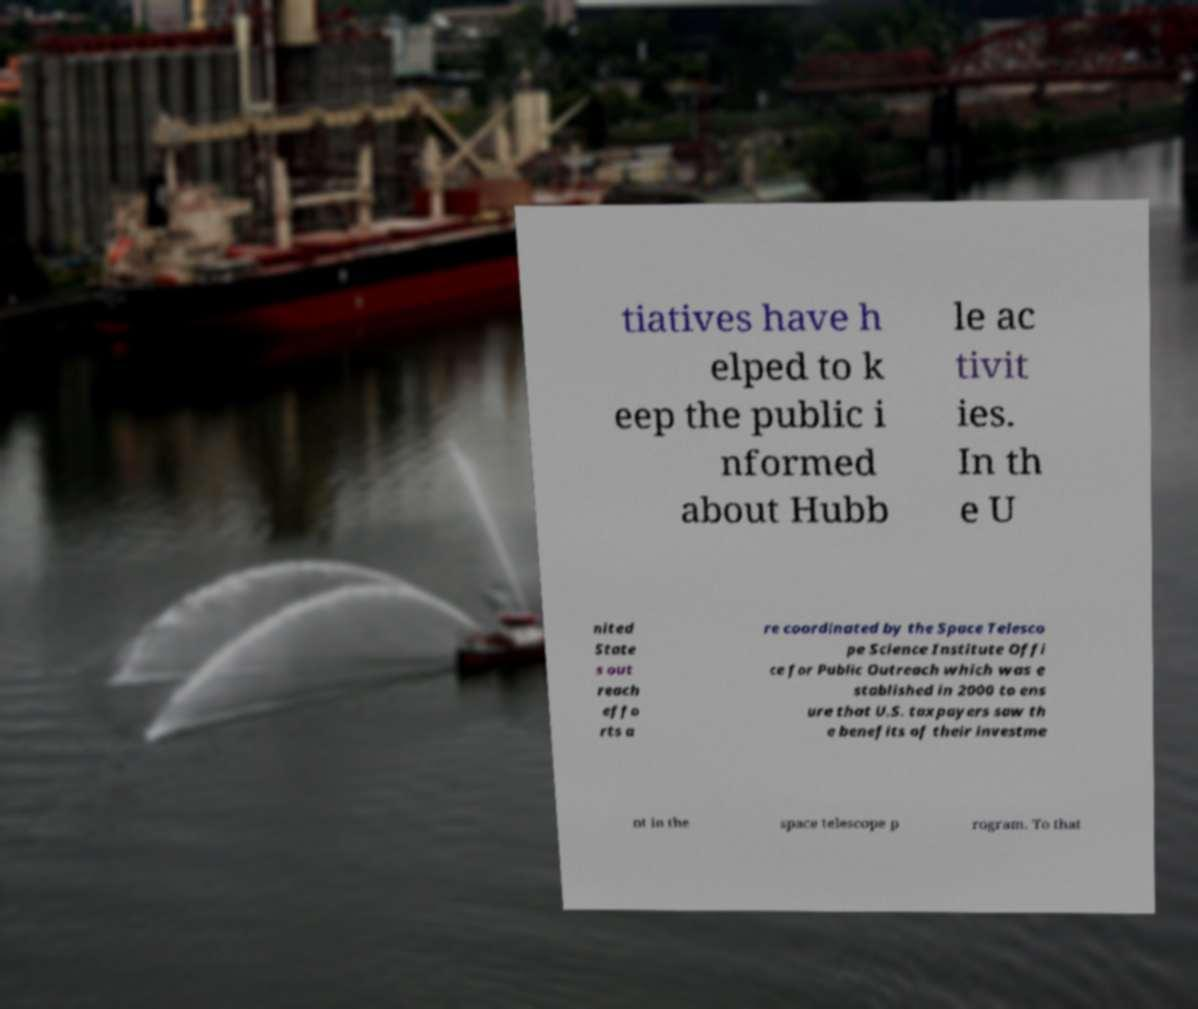For documentation purposes, I need the text within this image transcribed. Could you provide that? tiatives have h elped to k eep the public i nformed about Hubb le ac tivit ies. In th e U nited State s out reach effo rts a re coordinated by the Space Telesco pe Science Institute Offi ce for Public Outreach which was e stablished in 2000 to ens ure that U.S. taxpayers saw th e benefits of their investme nt in the space telescope p rogram. To that 